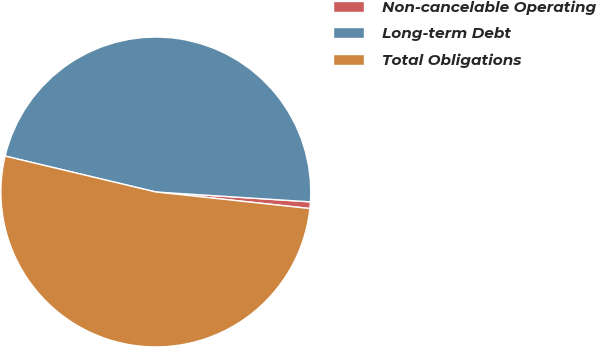Convert chart. <chart><loc_0><loc_0><loc_500><loc_500><pie_chart><fcel>Non-cancelable Operating<fcel>Long-term Debt<fcel>Total Obligations<nl><fcel>0.69%<fcel>47.29%<fcel>52.02%<nl></chart> 